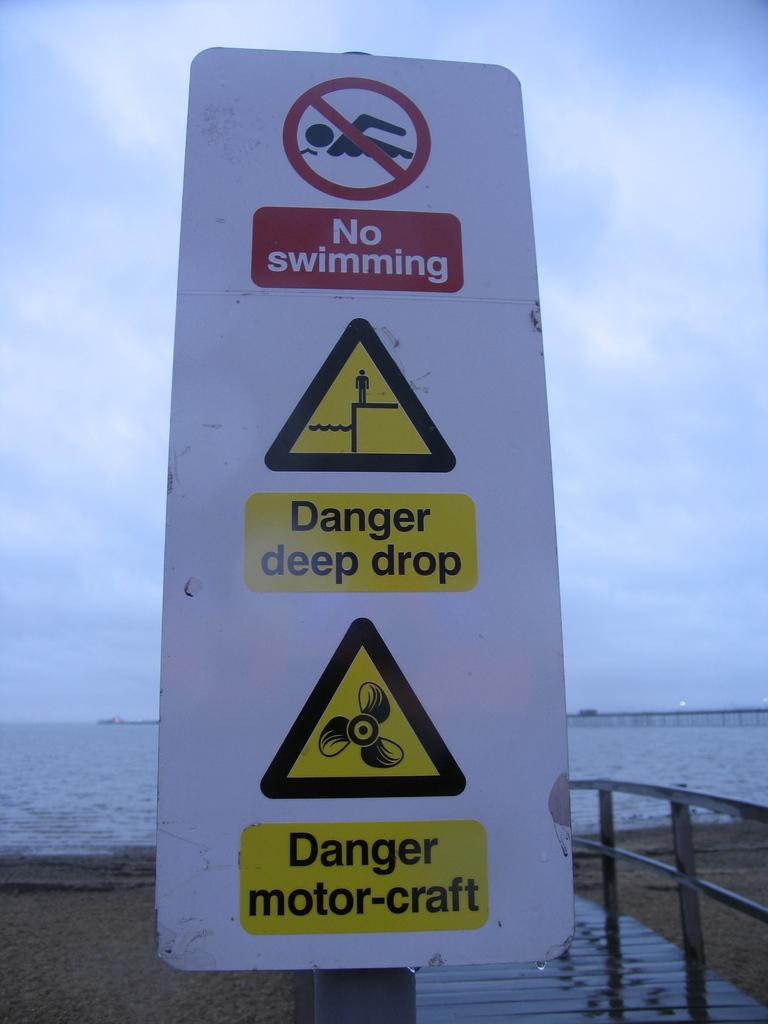<image>
Render a clear and concise summary of the photo. A sign on the beach warns visitors not to swim and of dangers in the water. 